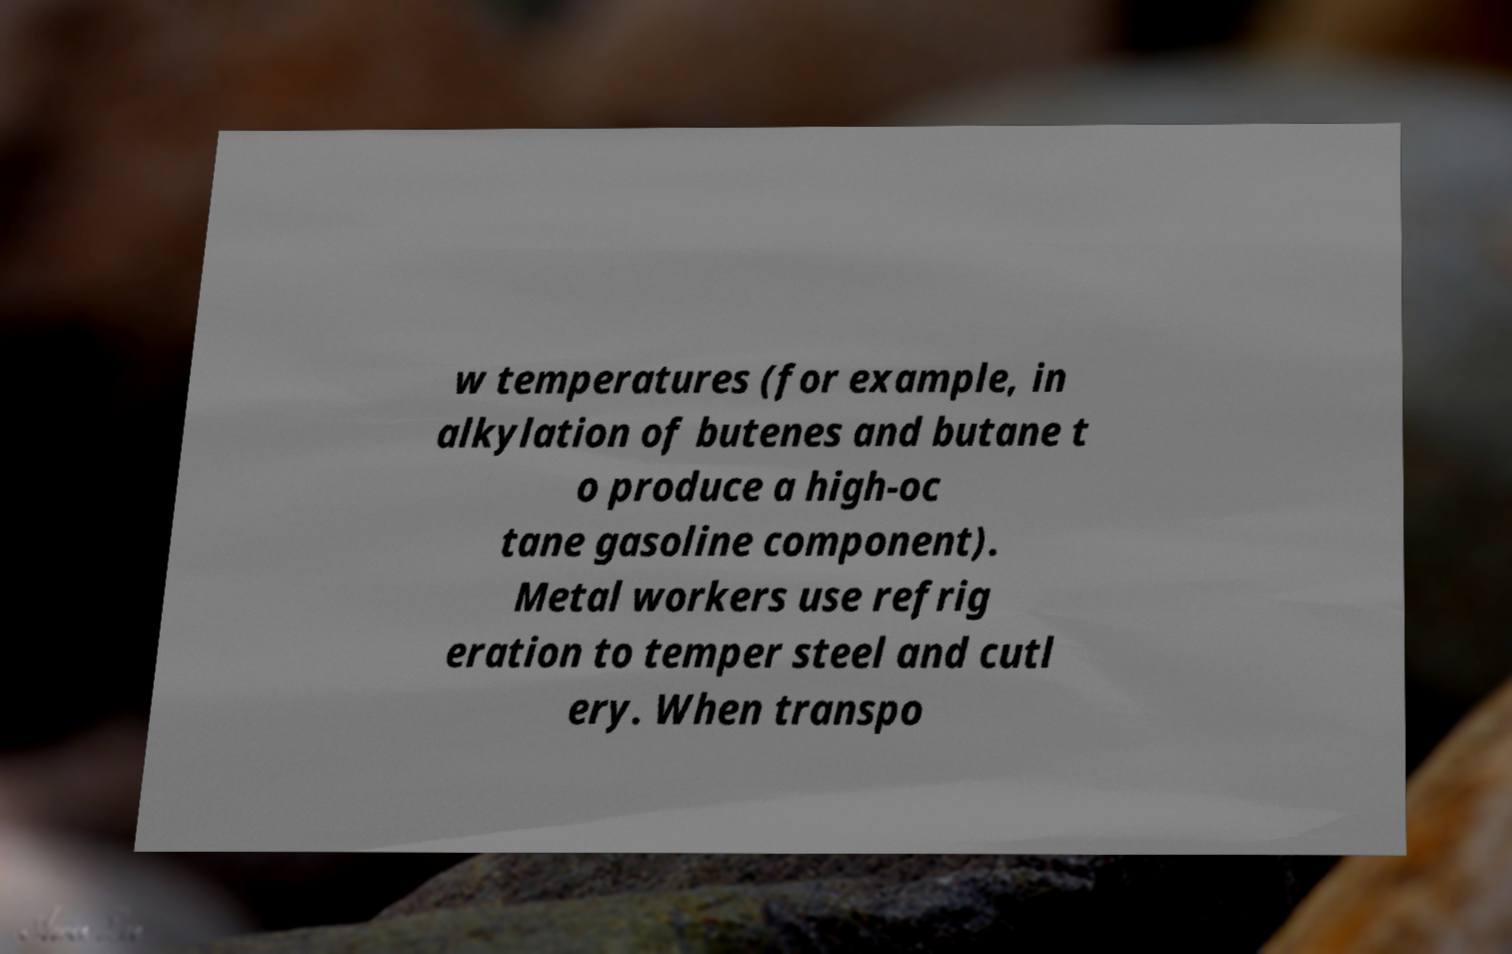Can you read and provide the text displayed in the image?This photo seems to have some interesting text. Can you extract and type it out for me? w temperatures (for example, in alkylation of butenes and butane t o produce a high-oc tane gasoline component). Metal workers use refrig eration to temper steel and cutl ery. When transpo 